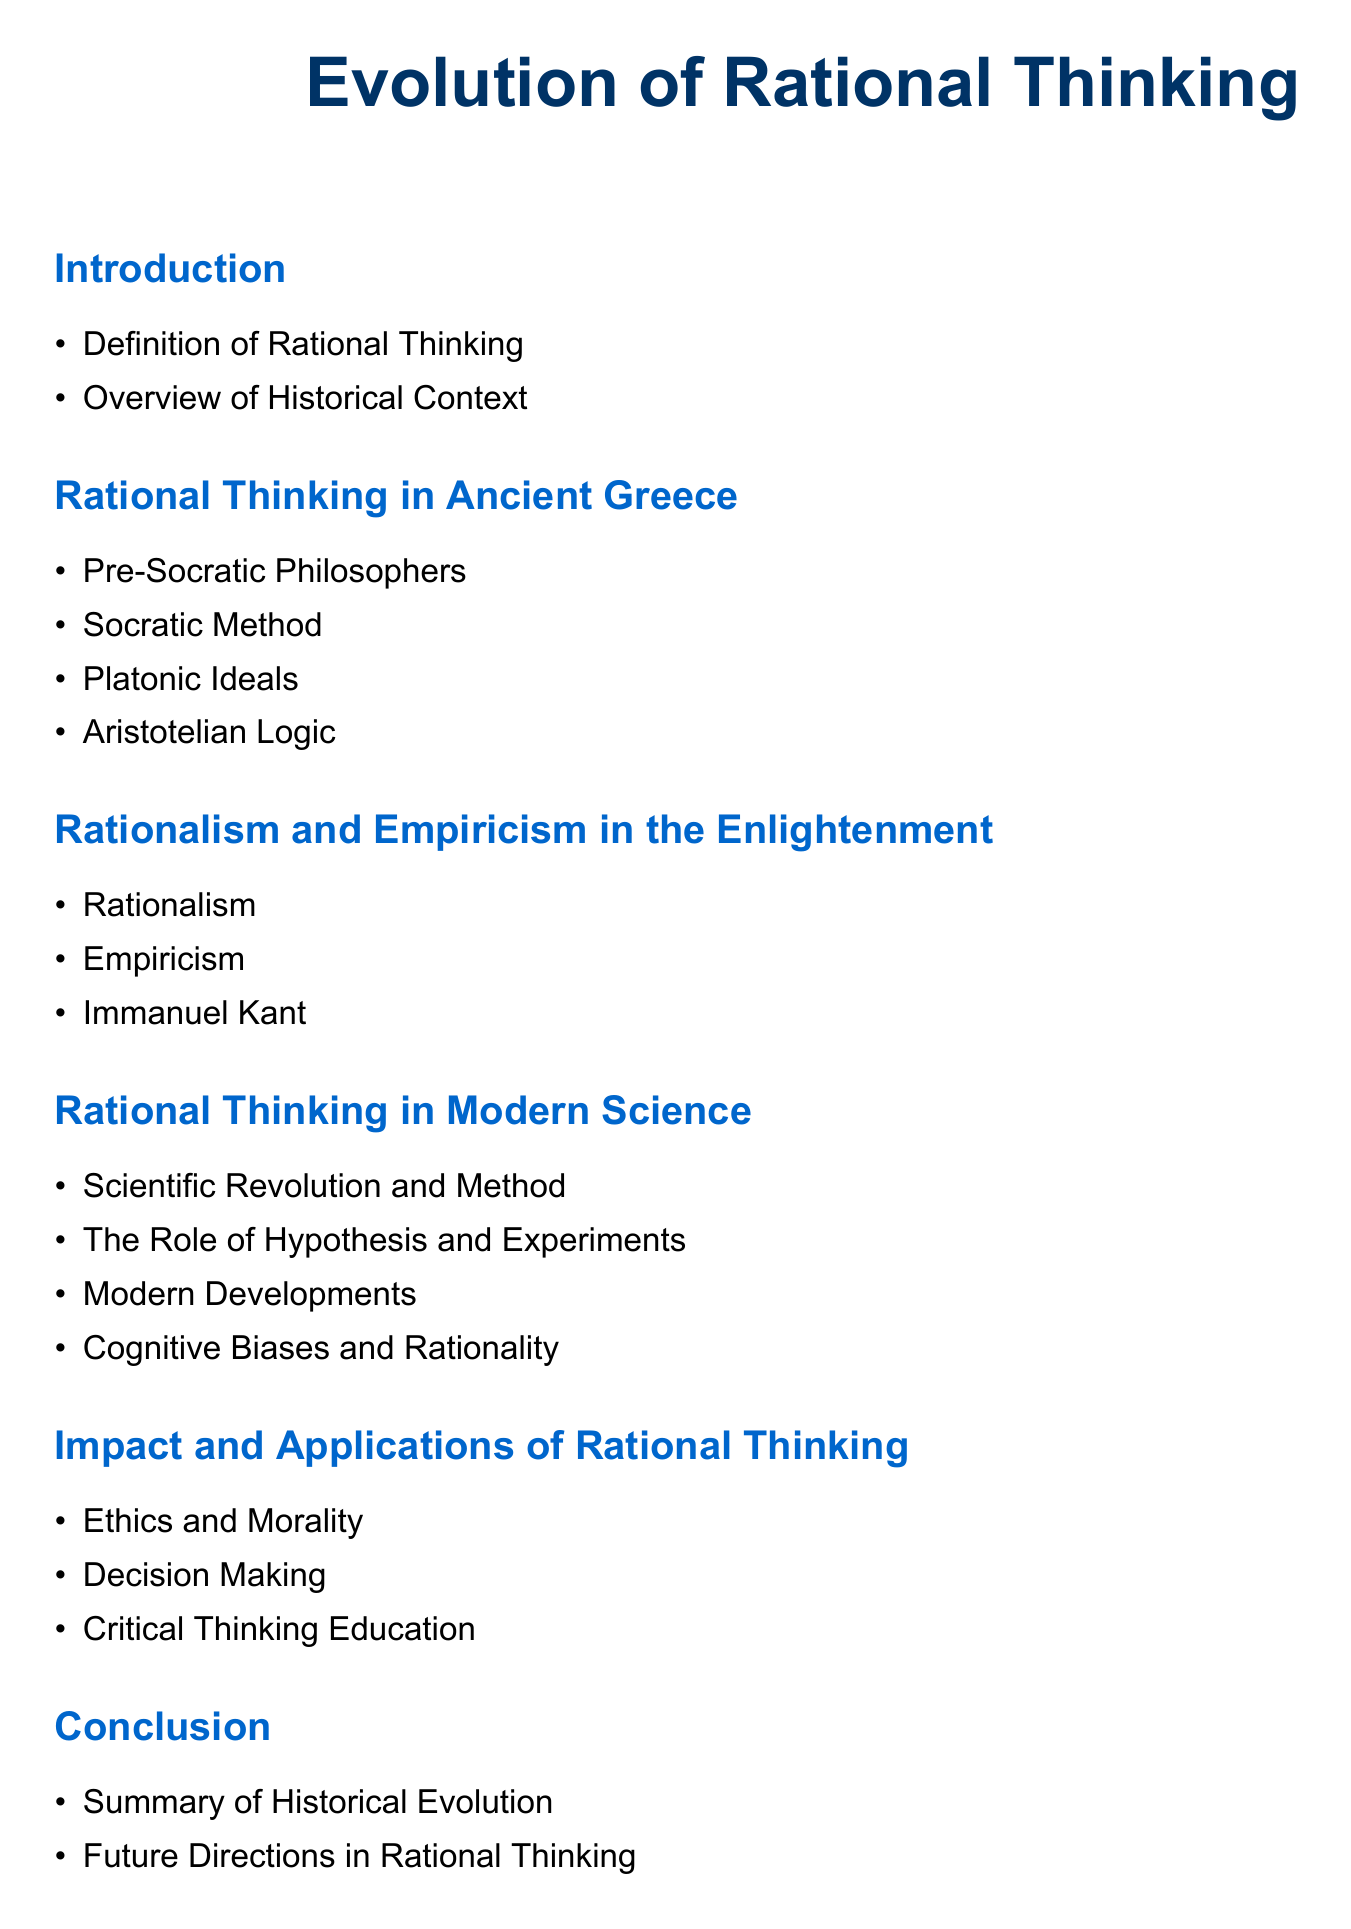What is the title of the document? The title is prominently displayed at the beginning of the document, indicating the main focus of the content.
Answer: Evolution of Rational Thinking What is one aspect covered in the Introduction section? The Introduction section includes items that provide foundational knowledge about rational thinking and context, as listed in the bullet points.
Answer: Definition of Rational Thinking Which philosophers are mentioned under Rational Thinking in Ancient Greece? This section highlights key figures foundational to rational thought in ancient times, listing them in bullet points.
Answer: Pre-Socratic Philosophers What does the Enlightenment section critically discuss that contrasts rationalism? This section addresses a major philosophical school that often stands in opposition to rationalism, alongside a key figure noted for their influence.
Answer: Empiricism What is one modern development addressed in the context of Rational Thinking in Modern Science? This section lists key topics relevant to rational thought as it has evolved, reflecting recent advancements.
Answer: Modern Developments How does the document relate rational thinking to decision making? The impact of rational thinking is outlined in a section specifically dedicated to its applications, touching on practical consequences.
Answer: Decision Making What is the concluding summary focused on? The conclusion summarizes the key points discussed throughout the document, particularly highlighting the historical context of rationality.
Answer: Summary of Historical Evolution 